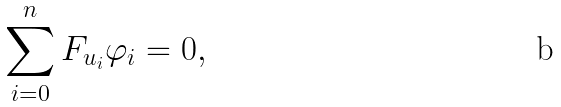Convert formula to latex. <formula><loc_0><loc_0><loc_500><loc_500>\sum _ { i = 0 } ^ { n } F _ { u _ { i } } \varphi _ { i } = 0 ,</formula> 